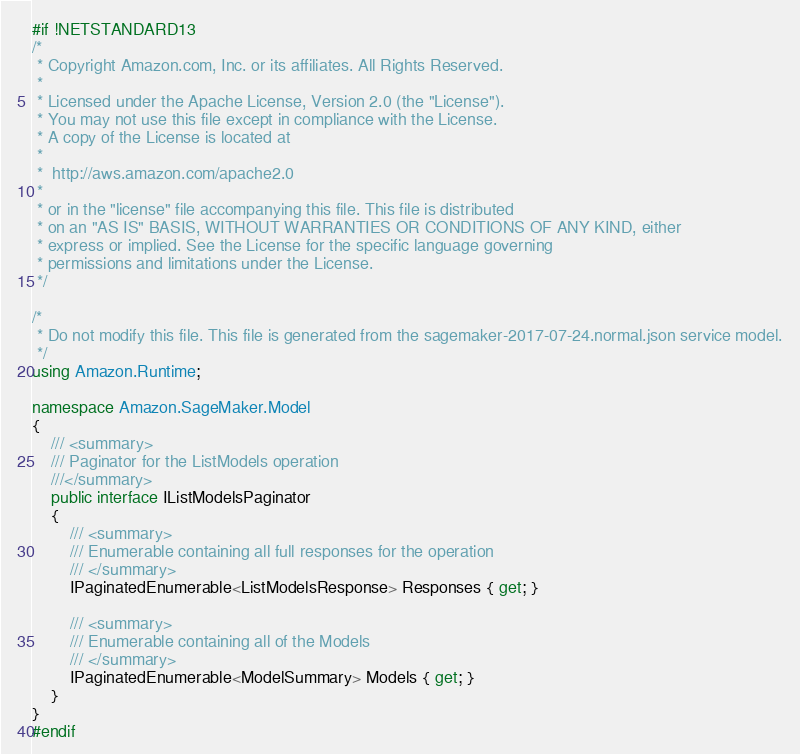Convert code to text. <code><loc_0><loc_0><loc_500><loc_500><_C#_>#if !NETSTANDARD13
/*
 * Copyright Amazon.com, Inc. or its affiliates. All Rights Reserved.
 * 
 * Licensed under the Apache License, Version 2.0 (the "License").
 * You may not use this file except in compliance with the License.
 * A copy of the License is located at
 * 
 *  http://aws.amazon.com/apache2.0
 * 
 * or in the "license" file accompanying this file. This file is distributed
 * on an "AS IS" BASIS, WITHOUT WARRANTIES OR CONDITIONS OF ANY KIND, either
 * express or implied. See the License for the specific language governing
 * permissions and limitations under the License.
 */

/*
 * Do not modify this file. This file is generated from the sagemaker-2017-07-24.normal.json service model.
 */
using Amazon.Runtime;

namespace Amazon.SageMaker.Model
{
    /// <summary>
    /// Paginator for the ListModels operation
    ///</summary>
    public interface IListModelsPaginator
    {
        /// <summary>
        /// Enumerable containing all full responses for the operation
        /// </summary>
        IPaginatedEnumerable<ListModelsResponse> Responses { get; }

        /// <summary>
        /// Enumerable containing all of the Models
        /// </summary>
        IPaginatedEnumerable<ModelSummary> Models { get; }
    }
}
#endif</code> 